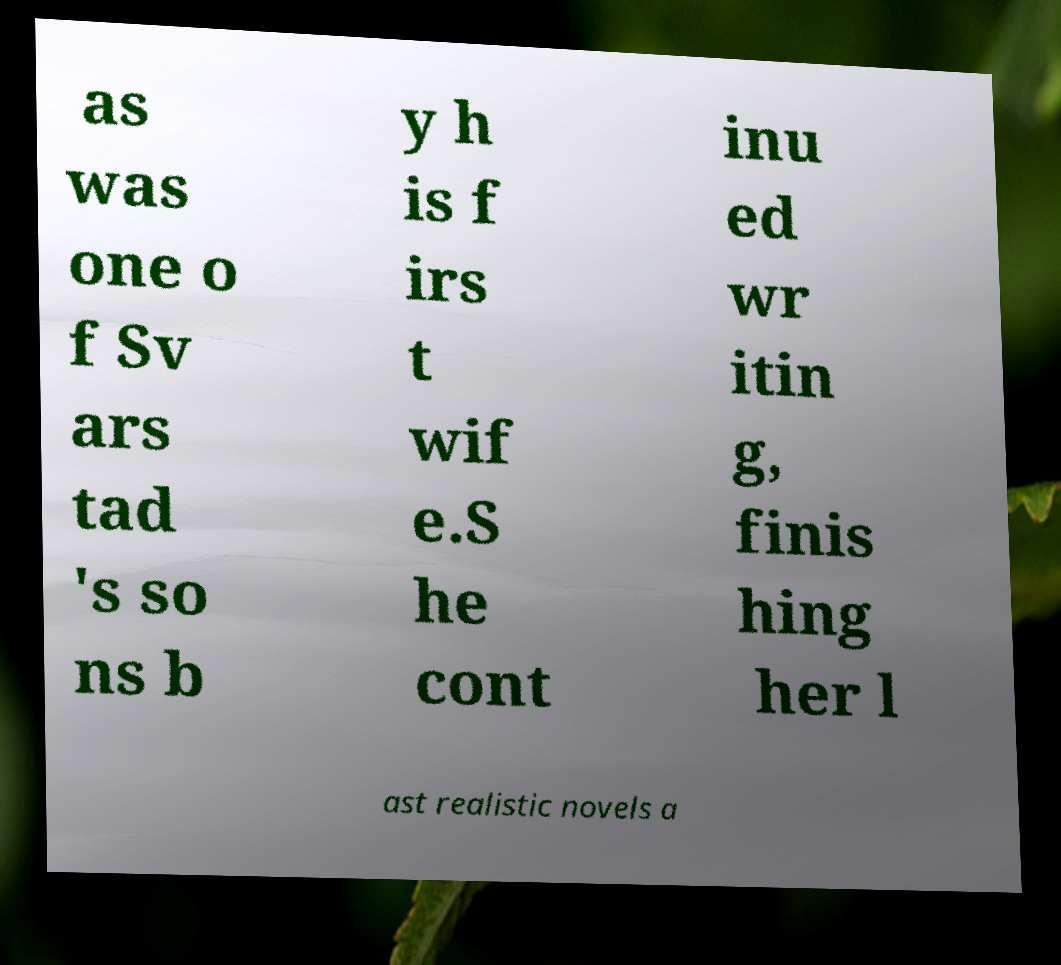Can you accurately transcribe the text from the provided image for me? as was one o f Sv ars tad 's so ns b y h is f irs t wif e.S he cont inu ed wr itin g, finis hing her l ast realistic novels a 